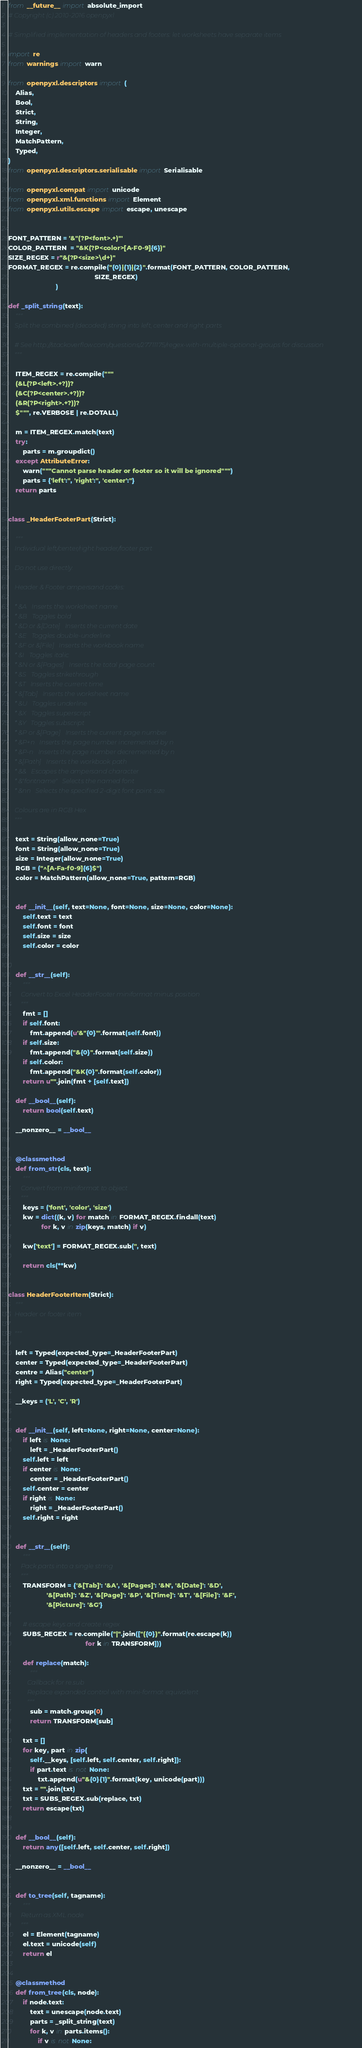<code> <loc_0><loc_0><loc_500><loc_500><_Python_>from __future__ import absolute_import
# Copyright (c) 2010-2016 openpyxl

# Simplified implementation of headers and footers: let worksheets have separate items

import re
from warnings import warn

from openpyxl.descriptors import (
    Alias,
    Bool,
    Strict,
    String,
    Integer,
    MatchPattern,
    Typed,
)
from openpyxl.descriptors.serialisable import Serialisable

from openpyxl.compat import unicode
from openpyxl.xml.functions import Element
from openpyxl.utils.escape import escape, unescape


FONT_PATTERN = '&"(?P<font>.+)"'
COLOR_PATTERN  = "&K(?P<color>[A-F0-9]{6})"
SIZE_REGEX = r"&(?P<size>\d+)"
FORMAT_REGEX = re.compile("{0}|{1}|{2}".format(FONT_PATTERN, COLOR_PATTERN,
                                               SIZE_REGEX)
                          )

def _split_string(text):
    """
    Split the combined (decoded) string into left, center and right parts

    # See http://stackoverflow.com/questions/27711175/regex-with-multiple-optional-groups for discussion
    """

    ITEM_REGEX = re.compile("""
    (&L(?P<left>.+?))?
    (&C(?P<center>.+?))?
    (&R(?P<right>.+?))?
    $""", re.VERBOSE | re.DOTALL)

    m = ITEM_REGEX.match(text)
    try:
        parts = m.groupdict()
    except AttributeError:
        warn("""Cannot parse header or footer so it will be ignored""")
        parts = {'left':'', 'right':'', 'center':''}
    return parts


class _HeaderFooterPart(Strict):

    """
    Individual left/center/right header/footer part

    Do not use directly.

    Header & Footer ampersand codes:

    * &A   Inserts the worksheet name
    * &B   Toggles bold
    * &D or &[Date]   Inserts the current date
    * &E   Toggles double-underline
    * &F or &[File]   Inserts the workbook name
    * &I   Toggles italic
    * &N or &[Pages]   Inserts the total page count
    * &S   Toggles strikethrough
    * &T   Inserts the current time
    * &[Tab]   Inserts the worksheet name
    * &U   Toggles underline
    * &X   Toggles superscript
    * &Y   Toggles subscript
    * &P or &[Page]   Inserts the current page number
    * &P+n   Inserts the page number incremented by n
    * &P-n   Inserts the page number decremented by n
    * &[Path]   Inserts the workbook path
    * &&   Escapes the ampersand character
    * &"fontname"   Selects the named font
    * &nn   Selects the specified 2-digit font point size

    Colours are in RGB Hex
    """

    text = String(allow_none=True)
    font = String(allow_none=True)
    size = Integer(allow_none=True)
    RGB = ("^[A-Fa-f0-9]{6}$")
    color = MatchPattern(allow_none=True, pattern=RGB)


    def __init__(self, text=None, font=None, size=None, color=None):
        self.text = text
        self.font = font
        self.size = size
        self.color = color


    def __str__(self):
        """
        Convert to Excel HeaderFooter miniformat minus position
        """
        fmt = []
        if self.font:
            fmt.append(u'&"{0}"'.format(self.font))
        if self.size:
            fmt.append("&{0}".format(self.size))
        if self.color:
            fmt.append("&K{0}".format(self.color))
        return u"".join(fmt + [self.text])

    def __bool__(self):
        return bool(self.text)

    __nonzero__ = __bool__


    @classmethod
    def from_str(cls, text):
        """
        Convert from miniformat to object
        """
        keys = ('font', 'color', 'size')
        kw = dict((k, v) for match in FORMAT_REGEX.findall(text)
                  for k, v in zip(keys, match) if v)

        kw['text'] = FORMAT_REGEX.sub('', text)

        return cls(**kw)


class HeaderFooterItem(Strict):
    """
    Header or footer item

    """

    left = Typed(expected_type=_HeaderFooterPart)
    center = Typed(expected_type=_HeaderFooterPart)
    centre = Alias("center")
    right = Typed(expected_type=_HeaderFooterPart)

    __keys = ('L', 'C', 'R')


    def __init__(self, left=None, right=None, center=None):
        if left is None:
            left = _HeaderFooterPart()
        self.left = left
        if center is None:
            center = _HeaderFooterPart()
        self.center = center
        if right is None:
            right = _HeaderFooterPart()
        self.right = right


    def __str__(self):
        """
        Pack parts into a single string
        """
        TRANSFORM = {'&[Tab]': '&A', '&[Pages]': '&N', '&[Date]': '&D',
                     '&[Path]': '&Z', '&[Page]': '&P', '&[Time]': '&T', '&[File]': '&F',
                     '&[Picture]': '&G'}

        # escape keys and create regex
        SUBS_REGEX = re.compile("|".join(["({0})".format(re.escape(k))
                                          for k in TRANSFORM]))

        def replace(match):
            """
            Callback for re.sub
            Replace expanded control with mini-format equivalent
            """
            sub = match.group(0)
            return TRANSFORM[sub]

        txt = []
        for key, part in zip(
            self.__keys, [self.left, self.center, self.right]):
            if part.text is not None:
                txt.append(u"&{0}{1}".format(key, unicode(part)))
        txt = "".join(txt)
        txt = SUBS_REGEX.sub(replace, txt)
        return escape(txt)


    def __bool__(self):
        return any([self.left, self.center, self.right])

    __nonzero__ = __bool__


    def to_tree(self, tagname):
        """
        Return as XML node
        """
        el = Element(tagname)
        el.text = unicode(self)
        return el


    @classmethod
    def from_tree(cls, node):
        if node.text:
            text = unescape(node.text)
            parts = _split_string(text)
            for k, v in parts.items():
                if v is not None:</code> 